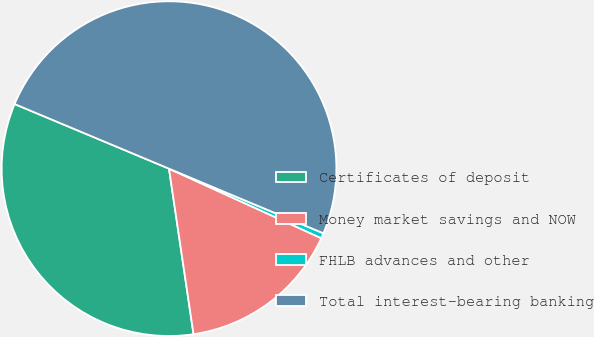Convert chart. <chart><loc_0><loc_0><loc_500><loc_500><pie_chart><fcel>Certificates of deposit<fcel>Money market savings and NOW<fcel>FHLB advances and other<fcel>Total interest-bearing banking<nl><fcel>33.65%<fcel>15.84%<fcel>0.51%<fcel>50.0%<nl></chart> 